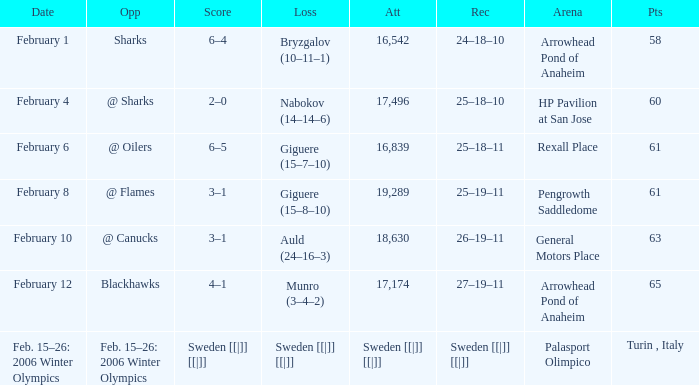What is the points when the score was 3–1, and record was 25–19–11? 61.0. 